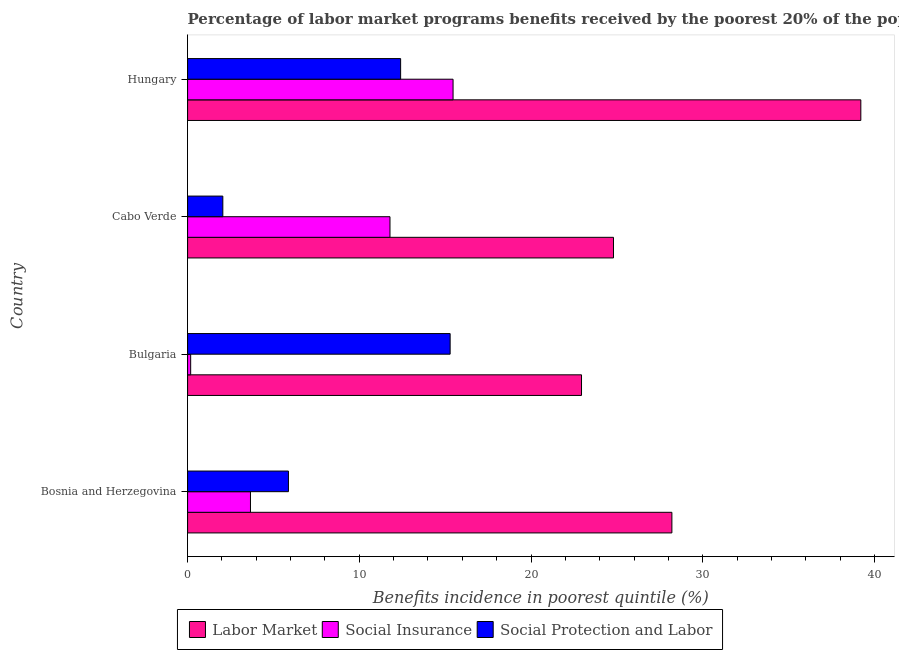How many groups of bars are there?
Offer a very short reply. 4. Are the number of bars per tick equal to the number of legend labels?
Provide a succinct answer. Yes. What is the label of the 1st group of bars from the top?
Give a very brief answer. Hungary. What is the percentage of benefits received due to social protection programs in Bulgaria?
Give a very brief answer. 15.29. Across all countries, what is the maximum percentage of benefits received due to social insurance programs?
Make the answer very short. 15.46. Across all countries, what is the minimum percentage of benefits received due to labor market programs?
Provide a succinct answer. 22.94. In which country was the percentage of benefits received due to labor market programs minimum?
Provide a short and direct response. Bulgaria. What is the total percentage of benefits received due to social protection programs in the graph?
Ensure brevity in your answer.  35.62. What is the difference between the percentage of benefits received due to social protection programs in Cabo Verde and that in Hungary?
Keep it short and to the point. -10.35. What is the difference between the percentage of benefits received due to social insurance programs in Bulgaria and the percentage of benefits received due to labor market programs in Bosnia and Herzegovina?
Ensure brevity in your answer.  -28.02. What is the average percentage of benefits received due to labor market programs per country?
Your response must be concise. 28.79. What is the difference between the percentage of benefits received due to social insurance programs and percentage of benefits received due to social protection programs in Bulgaria?
Offer a terse response. -15.11. What is the ratio of the percentage of benefits received due to social protection programs in Bosnia and Herzegovina to that in Hungary?
Keep it short and to the point. 0.47. Is the percentage of benefits received due to social protection programs in Bosnia and Herzegovina less than that in Hungary?
Provide a short and direct response. Yes. What is the difference between the highest and the second highest percentage of benefits received due to labor market programs?
Offer a very short reply. 11. What is the difference between the highest and the lowest percentage of benefits received due to social insurance programs?
Give a very brief answer. 15.28. Is the sum of the percentage of benefits received due to social protection programs in Bosnia and Herzegovina and Hungary greater than the maximum percentage of benefits received due to social insurance programs across all countries?
Provide a succinct answer. Yes. What does the 3rd bar from the top in Bosnia and Herzegovina represents?
Your answer should be compact. Labor Market. What does the 1st bar from the bottom in Bulgaria represents?
Provide a short and direct response. Labor Market. Is it the case that in every country, the sum of the percentage of benefits received due to labor market programs and percentage of benefits received due to social insurance programs is greater than the percentage of benefits received due to social protection programs?
Offer a terse response. Yes. Are all the bars in the graph horizontal?
Ensure brevity in your answer.  Yes. How many countries are there in the graph?
Offer a terse response. 4. What is the difference between two consecutive major ticks on the X-axis?
Give a very brief answer. 10. Does the graph contain any zero values?
Offer a terse response. No. How many legend labels are there?
Provide a short and direct response. 3. What is the title of the graph?
Ensure brevity in your answer.  Percentage of labor market programs benefits received by the poorest 20% of the population of countries. What is the label or title of the X-axis?
Offer a very short reply. Benefits incidence in poorest quintile (%). What is the label or title of the Y-axis?
Offer a terse response. Country. What is the Benefits incidence in poorest quintile (%) in Labor Market in Bosnia and Herzegovina?
Ensure brevity in your answer.  28.2. What is the Benefits incidence in poorest quintile (%) in Social Insurance in Bosnia and Herzegovina?
Give a very brief answer. 3.66. What is the Benefits incidence in poorest quintile (%) of Social Protection and Labor in Bosnia and Herzegovina?
Ensure brevity in your answer.  5.87. What is the Benefits incidence in poorest quintile (%) of Labor Market in Bulgaria?
Ensure brevity in your answer.  22.94. What is the Benefits incidence in poorest quintile (%) of Social Insurance in Bulgaria?
Keep it short and to the point. 0.18. What is the Benefits incidence in poorest quintile (%) of Social Protection and Labor in Bulgaria?
Ensure brevity in your answer.  15.29. What is the Benefits incidence in poorest quintile (%) of Labor Market in Cabo Verde?
Provide a succinct answer. 24.8. What is the Benefits incidence in poorest quintile (%) in Social Insurance in Cabo Verde?
Give a very brief answer. 11.79. What is the Benefits incidence in poorest quintile (%) of Social Protection and Labor in Cabo Verde?
Offer a very short reply. 2.05. What is the Benefits incidence in poorest quintile (%) of Labor Market in Hungary?
Provide a short and direct response. 39.21. What is the Benefits incidence in poorest quintile (%) in Social Insurance in Hungary?
Your answer should be compact. 15.46. What is the Benefits incidence in poorest quintile (%) of Social Protection and Labor in Hungary?
Offer a terse response. 12.41. Across all countries, what is the maximum Benefits incidence in poorest quintile (%) in Labor Market?
Keep it short and to the point. 39.21. Across all countries, what is the maximum Benefits incidence in poorest quintile (%) in Social Insurance?
Ensure brevity in your answer.  15.46. Across all countries, what is the maximum Benefits incidence in poorest quintile (%) of Social Protection and Labor?
Keep it short and to the point. 15.29. Across all countries, what is the minimum Benefits incidence in poorest quintile (%) in Labor Market?
Provide a succinct answer. 22.94. Across all countries, what is the minimum Benefits incidence in poorest quintile (%) in Social Insurance?
Your answer should be compact. 0.18. Across all countries, what is the minimum Benefits incidence in poorest quintile (%) in Social Protection and Labor?
Your answer should be very brief. 2.05. What is the total Benefits incidence in poorest quintile (%) of Labor Market in the graph?
Ensure brevity in your answer.  115.15. What is the total Benefits incidence in poorest quintile (%) in Social Insurance in the graph?
Make the answer very short. 31.09. What is the total Benefits incidence in poorest quintile (%) of Social Protection and Labor in the graph?
Offer a very short reply. 35.62. What is the difference between the Benefits incidence in poorest quintile (%) of Labor Market in Bosnia and Herzegovina and that in Bulgaria?
Your response must be concise. 5.26. What is the difference between the Benefits incidence in poorest quintile (%) in Social Insurance in Bosnia and Herzegovina and that in Bulgaria?
Provide a succinct answer. 3.48. What is the difference between the Benefits incidence in poorest quintile (%) of Social Protection and Labor in Bosnia and Herzegovina and that in Bulgaria?
Your answer should be compact. -9.42. What is the difference between the Benefits incidence in poorest quintile (%) of Labor Market in Bosnia and Herzegovina and that in Cabo Verde?
Your response must be concise. 3.4. What is the difference between the Benefits incidence in poorest quintile (%) of Social Insurance in Bosnia and Herzegovina and that in Cabo Verde?
Offer a very short reply. -8.12. What is the difference between the Benefits incidence in poorest quintile (%) of Social Protection and Labor in Bosnia and Herzegovina and that in Cabo Verde?
Give a very brief answer. 3.82. What is the difference between the Benefits incidence in poorest quintile (%) in Labor Market in Bosnia and Herzegovina and that in Hungary?
Your answer should be compact. -11. What is the difference between the Benefits incidence in poorest quintile (%) in Social Insurance in Bosnia and Herzegovina and that in Hungary?
Provide a succinct answer. -11.8. What is the difference between the Benefits incidence in poorest quintile (%) of Social Protection and Labor in Bosnia and Herzegovina and that in Hungary?
Your answer should be compact. -6.53. What is the difference between the Benefits incidence in poorest quintile (%) in Labor Market in Bulgaria and that in Cabo Verde?
Your answer should be very brief. -1.86. What is the difference between the Benefits incidence in poorest quintile (%) of Social Insurance in Bulgaria and that in Cabo Verde?
Your response must be concise. -11.61. What is the difference between the Benefits incidence in poorest quintile (%) in Social Protection and Labor in Bulgaria and that in Cabo Verde?
Keep it short and to the point. 13.24. What is the difference between the Benefits incidence in poorest quintile (%) of Labor Market in Bulgaria and that in Hungary?
Provide a short and direct response. -16.27. What is the difference between the Benefits incidence in poorest quintile (%) in Social Insurance in Bulgaria and that in Hungary?
Ensure brevity in your answer.  -15.28. What is the difference between the Benefits incidence in poorest quintile (%) of Social Protection and Labor in Bulgaria and that in Hungary?
Your answer should be very brief. 2.88. What is the difference between the Benefits incidence in poorest quintile (%) of Labor Market in Cabo Verde and that in Hungary?
Ensure brevity in your answer.  -14.4. What is the difference between the Benefits incidence in poorest quintile (%) in Social Insurance in Cabo Verde and that in Hungary?
Provide a succinct answer. -3.67. What is the difference between the Benefits incidence in poorest quintile (%) of Social Protection and Labor in Cabo Verde and that in Hungary?
Provide a succinct answer. -10.35. What is the difference between the Benefits incidence in poorest quintile (%) of Labor Market in Bosnia and Herzegovina and the Benefits incidence in poorest quintile (%) of Social Insurance in Bulgaria?
Ensure brevity in your answer.  28.02. What is the difference between the Benefits incidence in poorest quintile (%) in Labor Market in Bosnia and Herzegovina and the Benefits incidence in poorest quintile (%) in Social Protection and Labor in Bulgaria?
Keep it short and to the point. 12.91. What is the difference between the Benefits incidence in poorest quintile (%) in Social Insurance in Bosnia and Herzegovina and the Benefits incidence in poorest quintile (%) in Social Protection and Labor in Bulgaria?
Provide a short and direct response. -11.63. What is the difference between the Benefits incidence in poorest quintile (%) in Labor Market in Bosnia and Herzegovina and the Benefits incidence in poorest quintile (%) in Social Insurance in Cabo Verde?
Offer a very short reply. 16.42. What is the difference between the Benefits incidence in poorest quintile (%) in Labor Market in Bosnia and Herzegovina and the Benefits incidence in poorest quintile (%) in Social Protection and Labor in Cabo Verde?
Make the answer very short. 26.15. What is the difference between the Benefits incidence in poorest quintile (%) in Social Insurance in Bosnia and Herzegovina and the Benefits incidence in poorest quintile (%) in Social Protection and Labor in Cabo Verde?
Provide a succinct answer. 1.61. What is the difference between the Benefits incidence in poorest quintile (%) of Labor Market in Bosnia and Herzegovina and the Benefits incidence in poorest quintile (%) of Social Insurance in Hungary?
Provide a succinct answer. 12.74. What is the difference between the Benefits incidence in poorest quintile (%) of Labor Market in Bosnia and Herzegovina and the Benefits incidence in poorest quintile (%) of Social Protection and Labor in Hungary?
Your answer should be very brief. 15.8. What is the difference between the Benefits incidence in poorest quintile (%) in Social Insurance in Bosnia and Herzegovina and the Benefits incidence in poorest quintile (%) in Social Protection and Labor in Hungary?
Your response must be concise. -8.74. What is the difference between the Benefits incidence in poorest quintile (%) of Labor Market in Bulgaria and the Benefits incidence in poorest quintile (%) of Social Insurance in Cabo Verde?
Ensure brevity in your answer.  11.15. What is the difference between the Benefits incidence in poorest quintile (%) in Labor Market in Bulgaria and the Benefits incidence in poorest quintile (%) in Social Protection and Labor in Cabo Verde?
Keep it short and to the point. 20.89. What is the difference between the Benefits incidence in poorest quintile (%) of Social Insurance in Bulgaria and the Benefits incidence in poorest quintile (%) of Social Protection and Labor in Cabo Verde?
Provide a short and direct response. -1.87. What is the difference between the Benefits incidence in poorest quintile (%) in Labor Market in Bulgaria and the Benefits incidence in poorest quintile (%) in Social Insurance in Hungary?
Your response must be concise. 7.48. What is the difference between the Benefits incidence in poorest quintile (%) of Labor Market in Bulgaria and the Benefits incidence in poorest quintile (%) of Social Protection and Labor in Hungary?
Make the answer very short. 10.54. What is the difference between the Benefits incidence in poorest quintile (%) in Social Insurance in Bulgaria and the Benefits incidence in poorest quintile (%) in Social Protection and Labor in Hungary?
Provide a succinct answer. -12.23. What is the difference between the Benefits incidence in poorest quintile (%) in Labor Market in Cabo Verde and the Benefits incidence in poorest quintile (%) in Social Insurance in Hungary?
Keep it short and to the point. 9.34. What is the difference between the Benefits incidence in poorest quintile (%) of Labor Market in Cabo Verde and the Benefits incidence in poorest quintile (%) of Social Protection and Labor in Hungary?
Provide a short and direct response. 12.4. What is the difference between the Benefits incidence in poorest quintile (%) of Social Insurance in Cabo Verde and the Benefits incidence in poorest quintile (%) of Social Protection and Labor in Hungary?
Ensure brevity in your answer.  -0.62. What is the average Benefits incidence in poorest quintile (%) in Labor Market per country?
Offer a very short reply. 28.79. What is the average Benefits incidence in poorest quintile (%) of Social Insurance per country?
Give a very brief answer. 7.77. What is the average Benefits incidence in poorest quintile (%) in Social Protection and Labor per country?
Make the answer very short. 8.9. What is the difference between the Benefits incidence in poorest quintile (%) of Labor Market and Benefits incidence in poorest quintile (%) of Social Insurance in Bosnia and Herzegovina?
Your response must be concise. 24.54. What is the difference between the Benefits incidence in poorest quintile (%) of Labor Market and Benefits incidence in poorest quintile (%) of Social Protection and Labor in Bosnia and Herzegovina?
Give a very brief answer. 22.33. What is the difference between the Benefits incidence in poorest quintile (%) in Social Insurance and Benefits incidence in poorest quintile (%) in Social Protection and Labor in Bosnia and Herzegovina?
Keep it short and to the point. -2.21. What is the difference between the Benefits incidence in poorest quintile (%) in Labor Market and Benefits incidence in poorest quintile (%) in Social Insurance in Bulgaria?
Offer a terse response. 22.76. What is the difference between the Benefits incidence in poorest quintile (%) of Labor Market and Benefits incidence in poorest quintile (%) of Social Protection and Labor in Bulgaria?
Provide a succinct answer. 7.65. What is the difference between the Benefits incidence in poorest quintile (%) in Social Insurance and Benefits incidence in poorest quintile (%) in Social Protection and Labor in Bulgaria?
Keep it short and to the point. -15.11. What is the difference between the Benefits incidence in poorest quintile (%) in Labor Market and Benefits incidence in poorest quintile (%) in Social Insurance in Cabo Verde?
Your answer should be compact. 13.02. What is the difference between the Benefits incidence in poorest quintile (%) of Labor Market and Benefits incidence in poorest quintile (%) of Social Protection and Labor in Cabo Verde?
Provide a short and direct response. 22.75. What is the difference between the Benefits incidence in poorest quintile (%) of Social Insurance and Benefits incidence in poorest quintile (%) of Social Protection and Labor in Cabo Verde?
Offer a very short reply. 9.73. What is the difference between the Benefits incidence in poorest quintile (%) in Labor Market and Benefits incidence in poorest quintile (%) in Social Insurance in Hungary?
Your response must be concise. 23.75. What is the difference between the Benefits incidence in poorest quintile (%) in Labor Market and Benefits incidence in poorest quintile (%) in Social Protection and Labor in Hungary?
Give a very brief answer. 26.8. What is the difference between the Benefits incidence in poorest quintile (%) of Social Insurance and Benefits incidence in poorest quintile (%) of Social Protection and Labor in Hungary?
Give a very brief answer. 3.05. What is the ratio of the Benefits incidence in poorest quintile (%) of Labor Market in Bosnia and Herzegovina to that in Bulgaria?
Your answer should be compact. 1.23. What is the ratio of the Benefits incidence in poorest quintile (%) of Social Insurance in Bosnia and Herzegovina to that in Bulgaria?
Offer a terse response. 20.48. What is the ratio of the Benefits incidence in poorest quintile (%) of Social Protection and Labor in Bosnia and Herzegovina to that in Bulgaria?
Make the answer very short. 0.38. What is the ratio of the Benefits incidence in poorest quintile (%) in Labor Market in Bosnia and Herzegovina to that in Cabo Verde?
Offer a very short reply. 1.14. What is the ratio of the Benefits incidence in poorest quintile (%) of Social Insurance in Bosnia and Herzegovina to that in Cabo Verde?
Ensure brevity in your answer.  0.31. What is the ratio of the Benefits incidence in poorest quintile (%) in Social Protection and Labor in Bosnia and Herzegovina to that in Cabo Verde?
Offer a terse response. 2.86. What is the ratio of the Benefits incidence in poorest quintile (%) in Labor Market in Bosnia and Herzegovina to that in Hungary?
Provide a succinct answer. 0.72. What is the ratio of the Benefits incidence in poorest quintile (%) in Social Insurance in Bosnia and Herzegovina to that in Hungary?
Offer a terse response. 0.24. What is the ratio of the Benefits incidence in poorest quintile (%) in Social Protection and Labor in Bosnia and Herzegovina to that in Hungary?
Offer a very short reply. 0.47. What is the ratio of the Benefits incidence in poorest quintile (%) in Labor Market in Bulgaria to that in Cabo Verde?
Give a very brief answer. 0.92. What is the ratio of the Benefits incidence in poorest quintile (%) in Social Insurance in Bulgaria to that in Cabo Verde?
Offer a terse response. 0.02. What is the ratio of the Benefits incidence in poorest quintile (%) of Social Protection and Labor in Bulgaria to that in Cabo Verde?
Provide a succinct answer. 7.45. What is the ratio of the Benefits incidence in poorest quintile (%) of Labor Market in Bulgaria to that in Hungary?
Ensure brevity in your answer.  0.59. What is the ratio of the Benefits incidence in poorest quintile (%) in Social Insurance in Bulgaria to that in Hungary?
Your answer should be compact. 0.01. What is the ratio of the Benefits incidence in poorest quintile (%) of Social Protection and Labor in Bulgaria to that in Hungary?
Make the answer very short. 1.23. What is the ratio of the Benefits incidence in poorest quintile (%) of Labor Market in Cabo Verde to that in Hungary?
Your answer should be compact. 0.63. What is the ratio of the Benefits incidence in poorest quintile (%) in Social Insurance in Cabo Verde to that in Hungary?
Make the answer very short. 0.76. What is the ratio of the Benefits incidence in poorest quintile (%) of Social Protection and Labor in Cabo Verde to that in Hungary?
Offer a very short reply. 0.17. What is the difference between the highest and the second highest Benefits incidence in poorest quintile (%) of Labor Market?
Ensure brevity in your answer.  11. What is the difference between the highest and the second highest Benefits incidence in poorest quintile (%) in Social Insurance?
Your response must be concise. 3.67. What is the difference between the highest and the second highest Benefits incidence in poorest quintile (%) of Social Protection and Labor?
Provide a short and direct response. 2.88. What is the difference between the highest and the lowest Benefits incidence in poorest quintile (%) in Labor Market?
Provide a succinct answer. 16.27. What is the difference between the highest and the lowest Benefits incidence in poorest quintile (%) of Social Insurance?
Your answer should be compact. 15.28. What is the difference between the highest and the lowest Benefits incidence in poorest quintile (%) in Social Protection and Labor?
Keep it short and to the point. 13.24. 